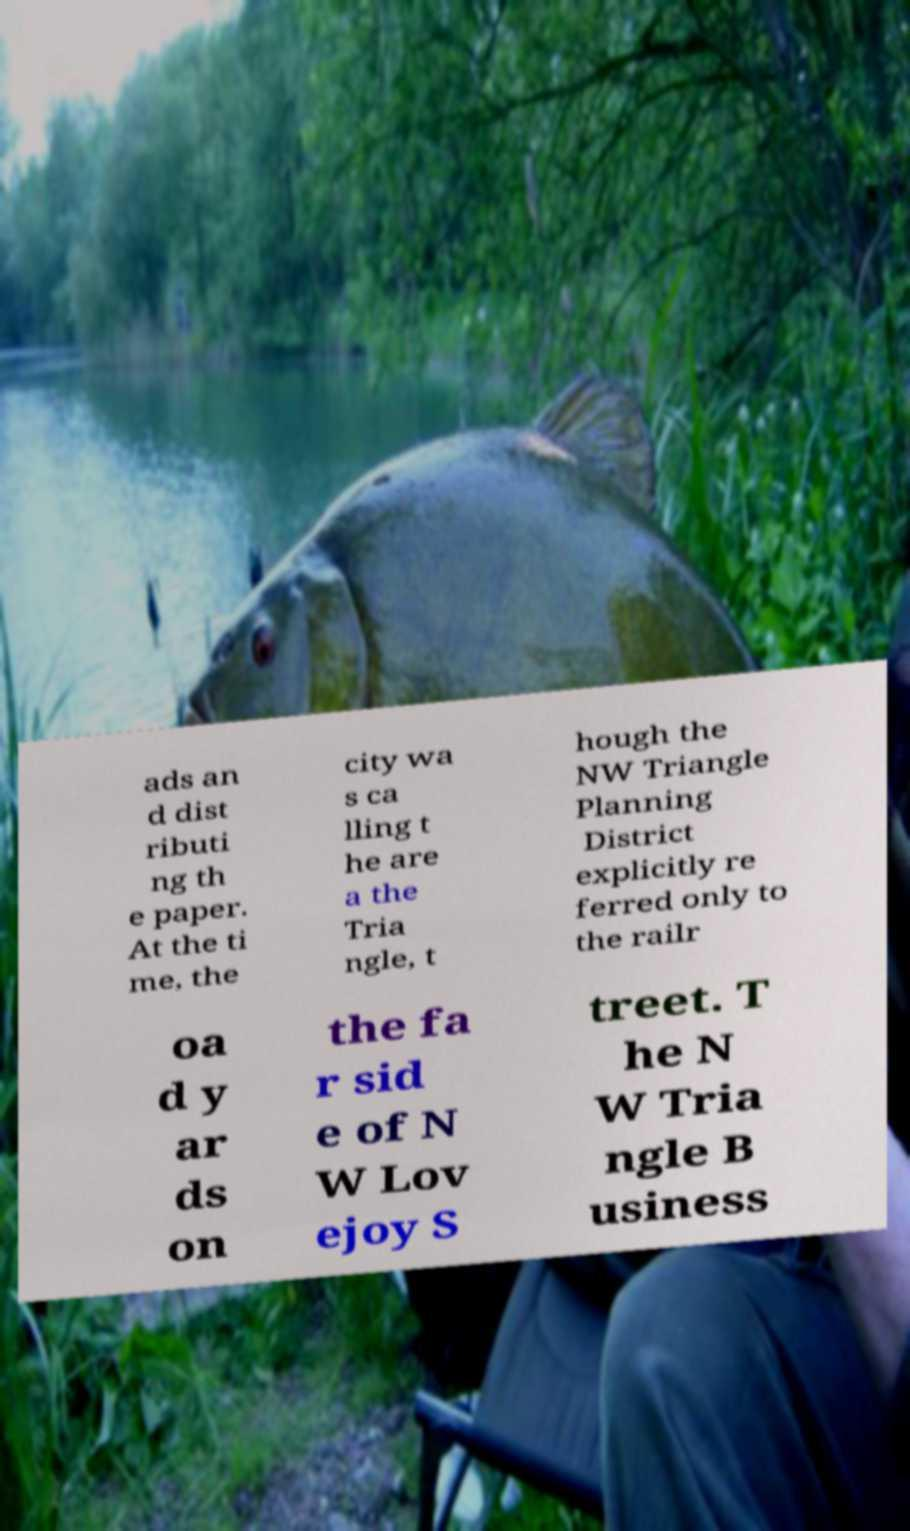Could you assist in decoding the text presented in this image and type it out clearly? ads an d dist ributi ng th e paper. At the ti me, the city wa s ca lling t he are a the Tria ngle, t hough the NW Triangle Planning District explicitly re ferred only to the railr oa d y ar ds on the fa r sid e of N W Lov ejoy S treet. T he N W Tria ngle B usiness 